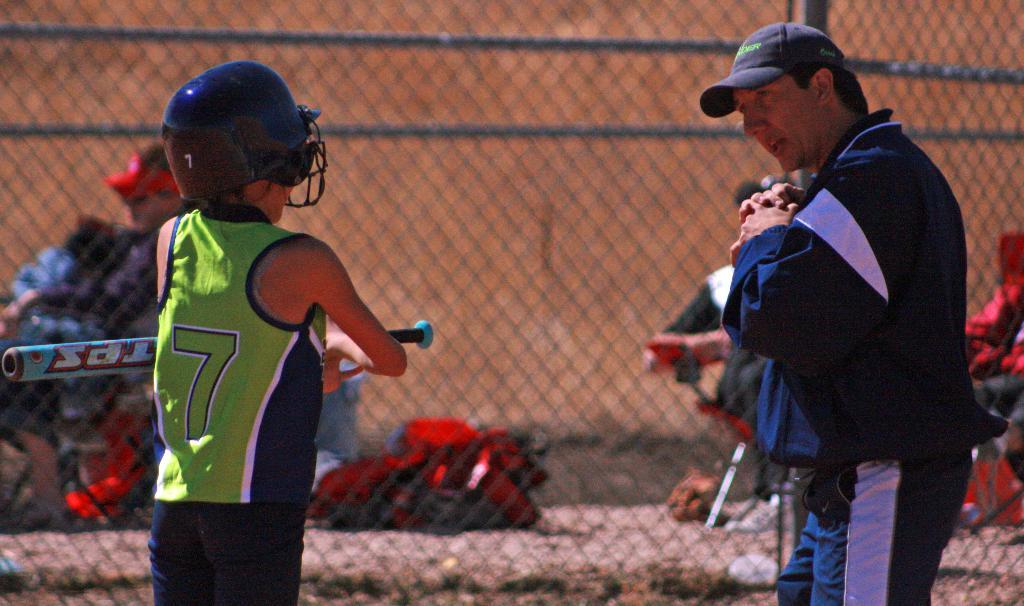How many people are present in the image? There are four persons in the image. What are the positions of the people in the image? Two of the persons are sitting on chairs, and two are standing on the ground. What can be seen in the background of the image? There is a fence in the image. What else is present on the ground in the image? There are other objects on the ground in the image. What type of finger can be seen holding a tiger in the image? There is no finger or tiger present in the image. How many trains are visible in the image? There are no trains visible in the image. 